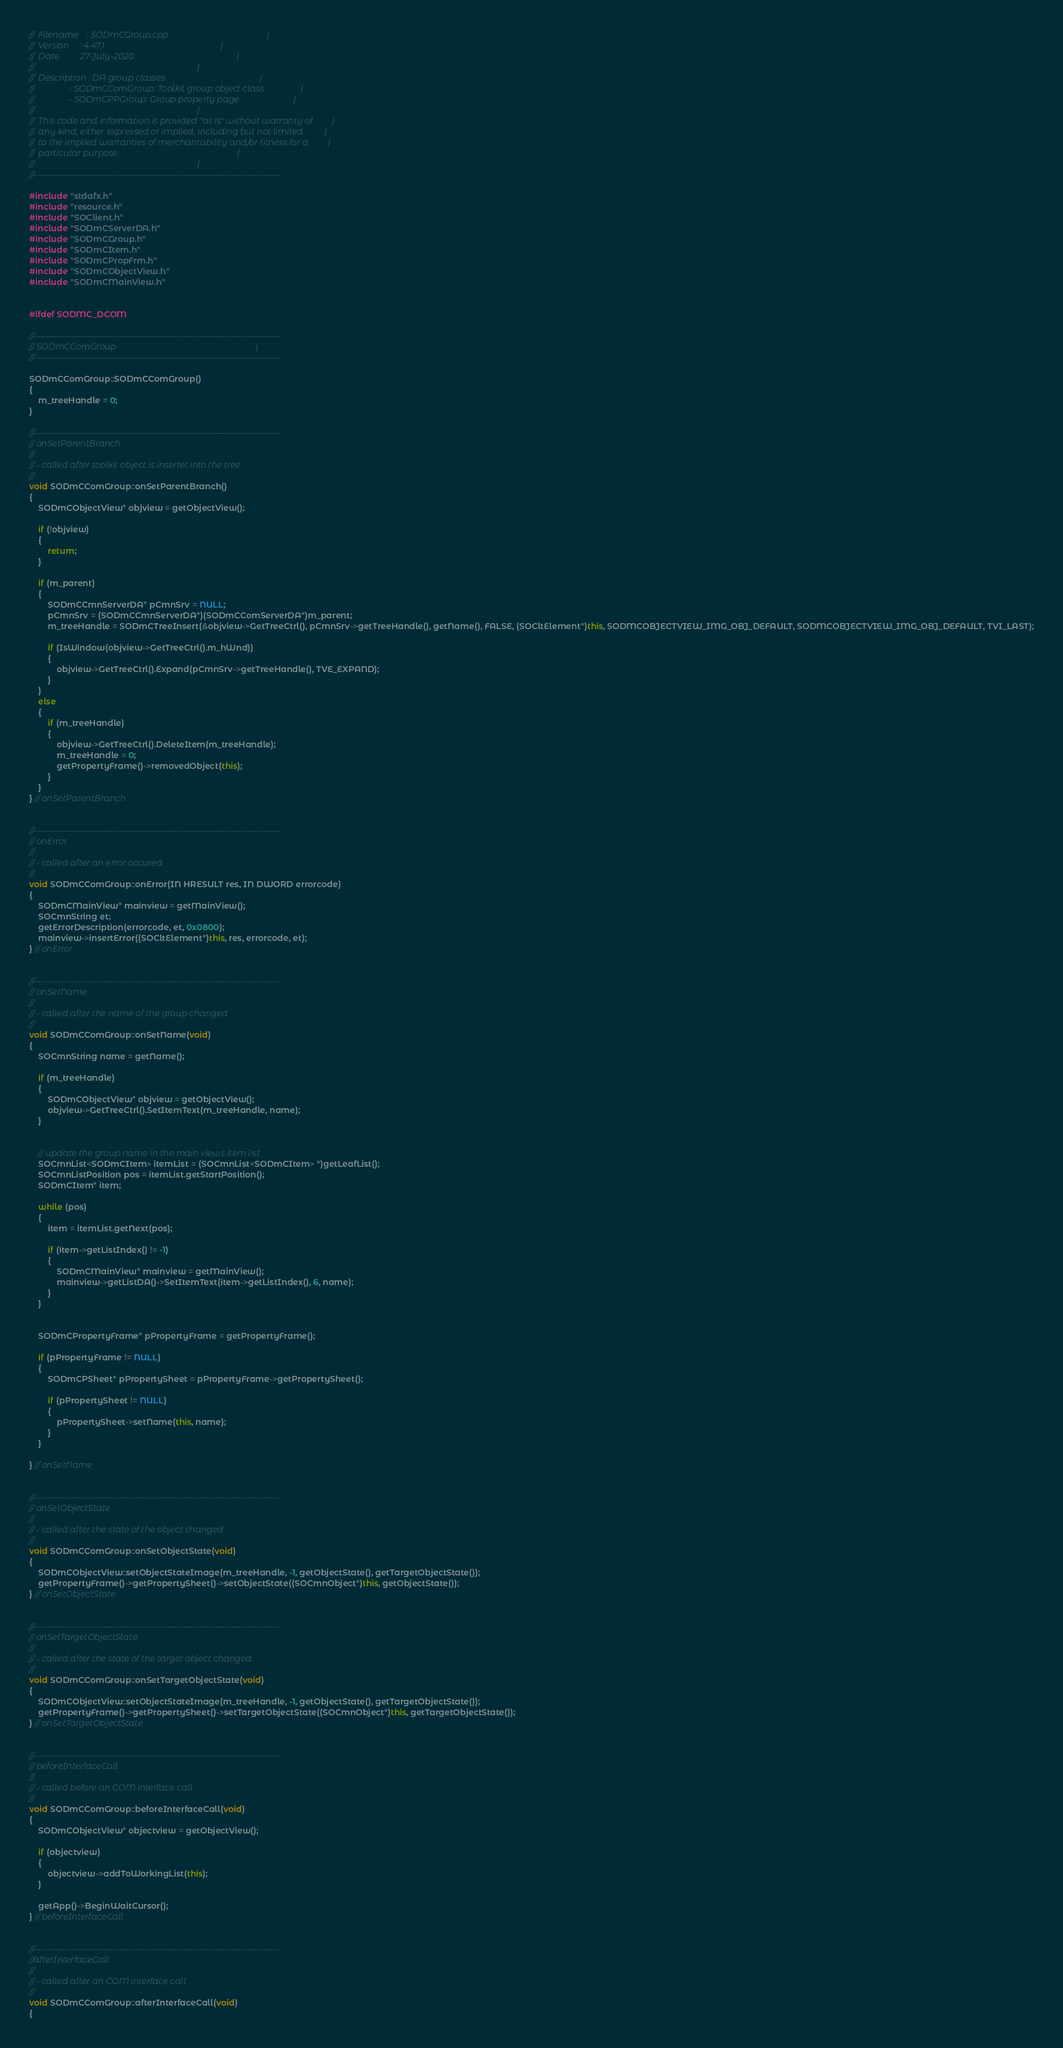<code> <loc_0><loc_0><loc_500><loc_500><_C++_>//  Filename    : SODmCGroup.cpp                                              |
//  Version     : 4.47.1                                                      |
//  Date        : 27-July-2020                                                |
//                                                                            |
//  Description : DA group classes                                            |
//                - SODmCComGroup: Toolkit group object class                 |
//                - SODmCPPGroup: Group property page                         |
//                                                                            |
//  This code and information is provided "as is" without warranty of         |
//  any kind, either expressed or implied, including but not limited          |
//  to the implied warranties of merchantability and/or fitness for a         |
//  particular purpose.                                                       |
//                                                                            |
//-----------------------------------------------------------------------------

#include "stdafx.h"
#include "resource.h"
#include "SOClient.h"
#include "SODmCServerDA.h"
#include "SODmCGroup.h"
#include "SODmCItem.h"
#include "SODmCPropFrm.h"
#include "SODmCObjectView.h"
#include "SODmCMainView.h"


#ifdef SODMC_DCOM

//-----------------------------------------------------------------------------
// SODmCComGroup                                                                 |
//-----------------------------------------------------------------------------

SODmCComGroup::SODmCComGroup()
{
	m_treeHandle = 0;
}

//-----------------------------------------------------------------------------
// onSetParentBranch
//
// - called after toolkit object is insertet into the tree
//
void SODmCComGroup::onSetParentBranch()
{
	SODmCObjectView* objview = getObjectView();

	if (!objview)
	{
		return;
	}

	if (m_parent)
	{
		SODmCCmnServerDA* pCmnSrv = NULL;
		pCmnSrv = (SODmCCmnServerDA*)(SODmCComServerDA*)m_parent;
		m_treeHandle = SODmCTreeInsert(&objview->GetTreeCtrl(), pCmnSrv->getTreeHandle(), getName(), FALSE, (SOCltElement*)this, SODMCOBJECTVIEW_IMG_OBJ_DEFAULT, SODMCOBJECTVIEW_IMG_OBJ_DEFAULT, TVI_LAST);

		if (IsWindow(objview->GetTreeCtrl().m_hWnd))
		{
			objview->GetTreeCtrl().Expand(pCmnSrv->getTreeHandle(), TVE_EXPAND);
		}
	}
	else
	{
		if (m_treeHandle)
		{
			objview->GetTreeCtrl().DeleteItem(m_treeHandle);
			m_treeHandle = 0;
			getPropertyFrame()->removedObject(this);
		}
	}
} // onSetParentBranch


//-----------------------------------------------------------------------------
// onError
//
// - called after an error occured
//
void SODmCComGroup::onError(IN HRESULT res, IN DWORD errorcode)
{
	SODmCMainView* mainview = getMainView();
	SOCmnString et;
	getErrorDescription(errorcode, et, 0x0800);
	mainview->insertError((SOCltElement*)this, res, errorcode, et);
} // onError


//-----------------------------------------------------------------------------
// onSetName
//
// - called after the name of the group changed
//
void SODmCComGroup::onSetName(void)
{
	SOCmnString name = getName();

	if (m_treeHandle)
	{
		SODmCObjectView* objview = getObjectView();
		objview->GetTreeCtrl().SetItemText(m_treeHandle, name);
	}


	// update the group name in the main views item list
	SOCmnList<SODmCItem> itemList = (SOCmnList<SODmCItem> *)getLeafList();
	SOCmnListPosition pos = itemList.getStartPosition();
	SODmCItem* item;

	while (pos)
	{
		item = itemList.getNext(pos);

		if (item->getListIndex() != -1)
		{
			SODmCMainView* mainview = getMainView();
			mainview->getListDA()->SetItemText(item->getListIndex(), 6, name);
		}
	}


	SODmCPropertyFrame* pPropertyFrame = getPropertyFrame();
	
	if (pPropertyFrame != NULL)
	{
		SODmCPSheet* pPropertySheet = pPropertyFrame->getPropertySheet();

		if (pPropertySheet != NULL)
		{
			pPropertySheet->setName(this, name);
		}		
	}

} // onSetName


//-----------------------------------------------------------------------------
// onSetObjectState
//
// - called after the state of the object changed
//
void SODmCComGroup::onSetObjectState(void)
{
	SODmCObjectView::setObjectStateImage(m_treeHandle, -1, getObjectState(), getTargetObjectState());
	getPropertyFrame()->getPropertySheet()->setObjectState((SOCmnObject*)this, getObjectState());
} // onSetObjectState


//-----------------------------------------------------------------------------
// onSetTargetObjectState
//
// - called after the state of the target object changed
//
void SODmCComGroup::onSetTargetObjectState(void)
{
	SODmCObjectView::setObjectStateImage(m_treeHandle, -1, getObjectState(), getTargetObjectState());
	getPropertyFrame()->getPropertySheet()->setTargetObjectState((SOCmnObject*)this, getTargetObjectState());
} // onSetTargetObjectState


//-----------------------------------------------------------------------------
// beforeInterfaceCall
//
// - called before an COM interface call
//
void SODmCComGroup::beforeInterfaceCall(void)
{
	SODmCObjectView* objectview = getObjectView();

	if (objectview)
	{
		objectview->addToWorkingList(this);
	}

	getApp()->BeginWaitCursor();
} // beforeInterfaceCall


//-----------------------------------------------------------------------------
//afterInterfaceCall
//
// - called after an COM interface call
//
void SODmCComGroup::afterInterfaceCall(void)
{</code> 